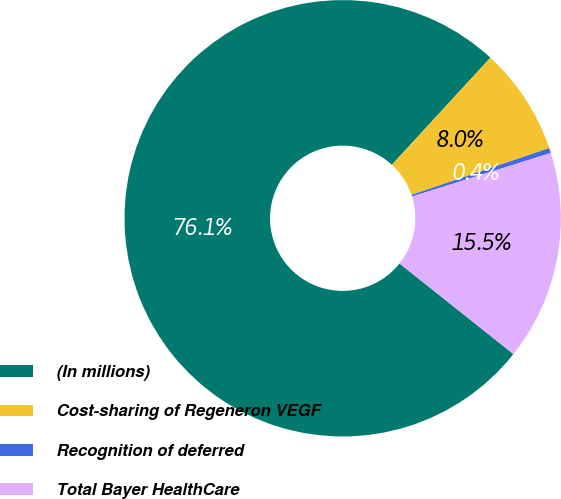Convert chart. <chart><loc_0><loc_0><loc_500><loc_500><pie_chart><fcel>(In millions)<fcel>Cost-sharing of Regeneron VEGF<fcel>Recognition of deferred<fcel>Total Bayer HealthCare<nl><fcel>76.14%<fcel>7.95%<fcel>0.38%<fcel>15.53%<nl></chart> 